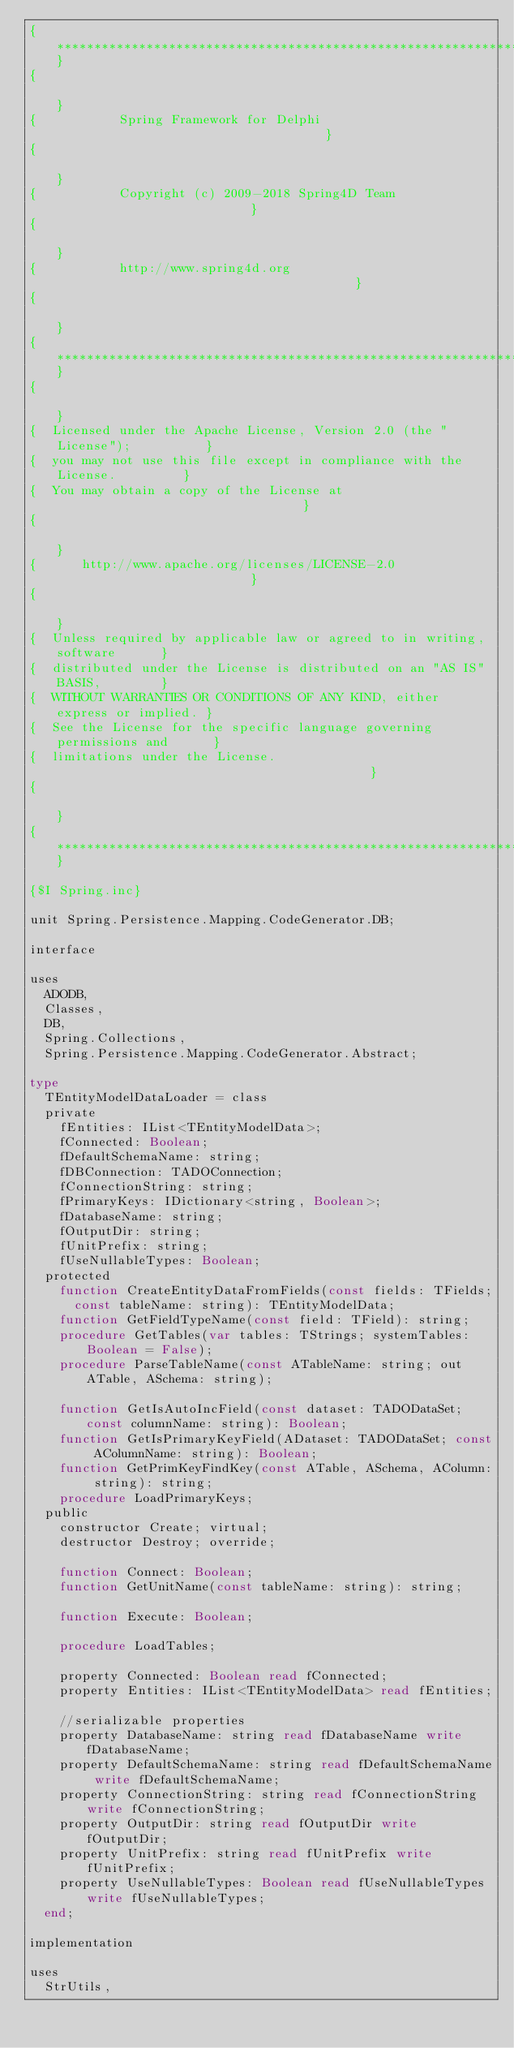<code> <loc_0><loc_0><loc_500><loc_500><_Pascal_>{***************************************************************************}
{                                                                           }
{           Spring Framework for Delphi                                     }
{                                                                           }
{           Copyright (c) 2009-2018 Spring4D Team                           }
{                                                                           }
{           http://www.spring4d.org                                         }
{                                                                           }
{***************************************************************************}
{                                                                           }
{  Licensed under the Apache License, Version 2.0 (the "License");          }
{  you may not use this file except in compliance with the License.         }
{  You may obtain a copy of the License at                                  }
{                                                                           }
{      http://www.apache.org/licenses/LICENSE-2.0                           }
{                                                                           }
{  Unless required by applicable law or agreed to in writing, software      }
{  distributed under the License is distributed on an "AS IS" BASIS,        }
{  WITHOUT WARRANTIES OR CONDITIONS OF ANY KIND, either express or implied. }
{  See the License for the specific language governing permissions and      }
{  limitations under the License.                                           }
{                                                                           }
{***************************************************************************}

{$I Spring.inc}

unit Spring.Persistence.Mapping.CodeGenerator.DB;

interface

uses
  ADODB,
  Classes,
  DB,
  Spring.Collections,
  Spring.Persistence.Mapping.CodeGenerator.Abstract;

type
  TEntityModelDataLoader = class
  private
    fEntities: IList<TEntityModelData>;
    fConnected: Boolean;
    fDefaultSchemaName: string;
    fDBConnection: TADOConnection;
    fConnectionString: string;
    fPrimaryKeys: IDictionary<string, Boolean>;
    fDatabaseName: string;
    fOutputDir: string;
    fUnitPrefix: string;
    fUseNullableTypes: Boolean;
  protected
    function CreateEntityDataFromFields(const fields: TFields;
      const tableName: string): TEntityModelData;
    function GetFieldTypeName(const field: TField): string;
    procedure GetTables(var tables: TStrings; systemTables: Boolean = False);
    procedure ParseTableName(const ATableName: string; out ATable, ASchema: string);

    function GetIsAutoIncField(const dataset: TADODataSet; const columnName: string): Boolean;
    function GetIsPrimaryKeyField(ADataset: TADODataSet; const AColumnName: string): Boolean;
    function GetPrimKeyFindKey(const ATable, ASchema, AColumn: string): string;
    procedure LoadPrimaryKeys;
  public
    constructor Create; virtual;
    destructor Destroy; override;

    function Connect: Boolean;
    function GetUnitName(const tableName: string): string;

    function Execute: Boolean;

    procedure LoadTables;

    property Connected: Boolean read fConnected;
    property Entities: IList<TEntityModelData> read fEntities;

    //serializable properties
    property DatabaseName: string read fDatabaseName write fDatabaseName;
    property DefaultSchemaName: string read fDefaultSchemaName write fDefaultSchemaName;
    property ConnectionString: string read fConnectionString write fConnectionString;
    property OutputDir: string read fOutputDir write fOutputDir;
    property UnitPrefix: string read fUnitPrefix write fUnitPrefix;
    property UseNullableTypes: Boolean read fUseNullableTypes write fUseNullableTypes;
  end;

implementation

uses
  StrUtils,</code> 